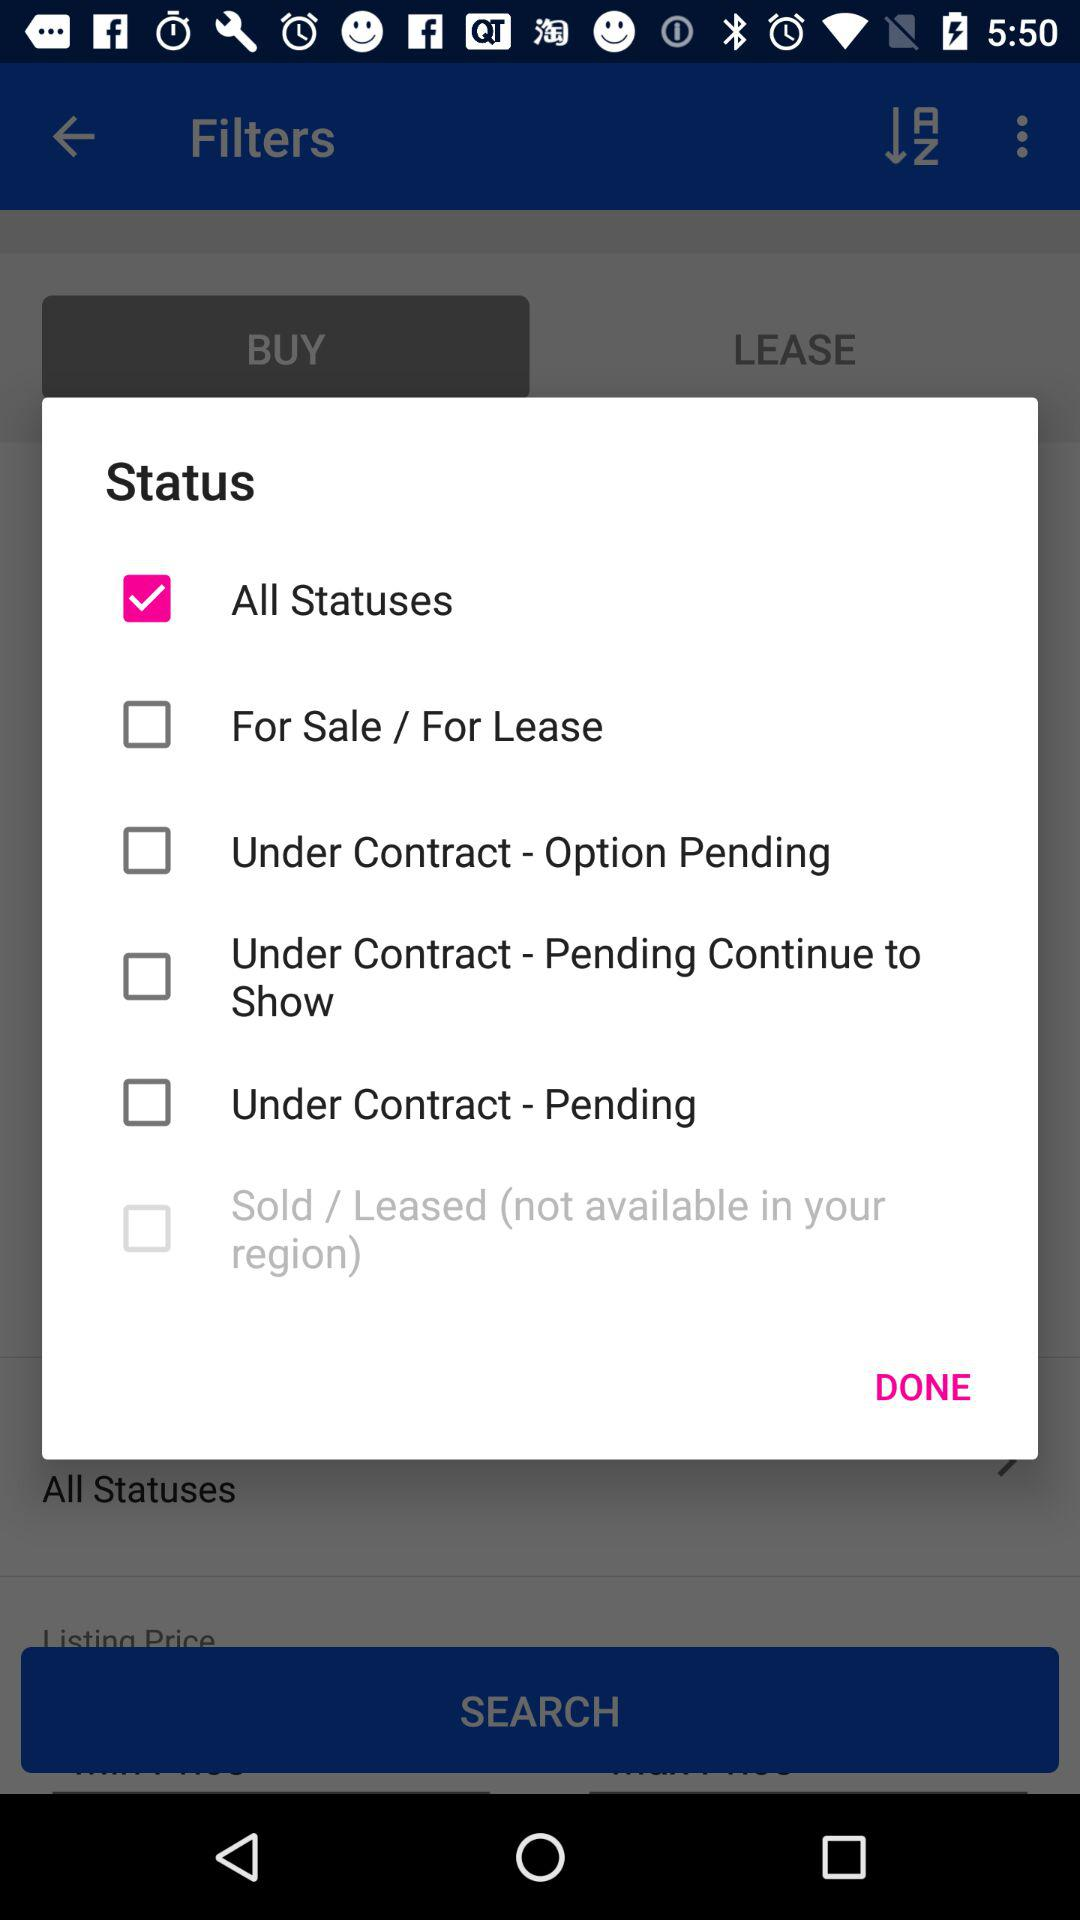What is the selected option? The selected option is "BUY". 